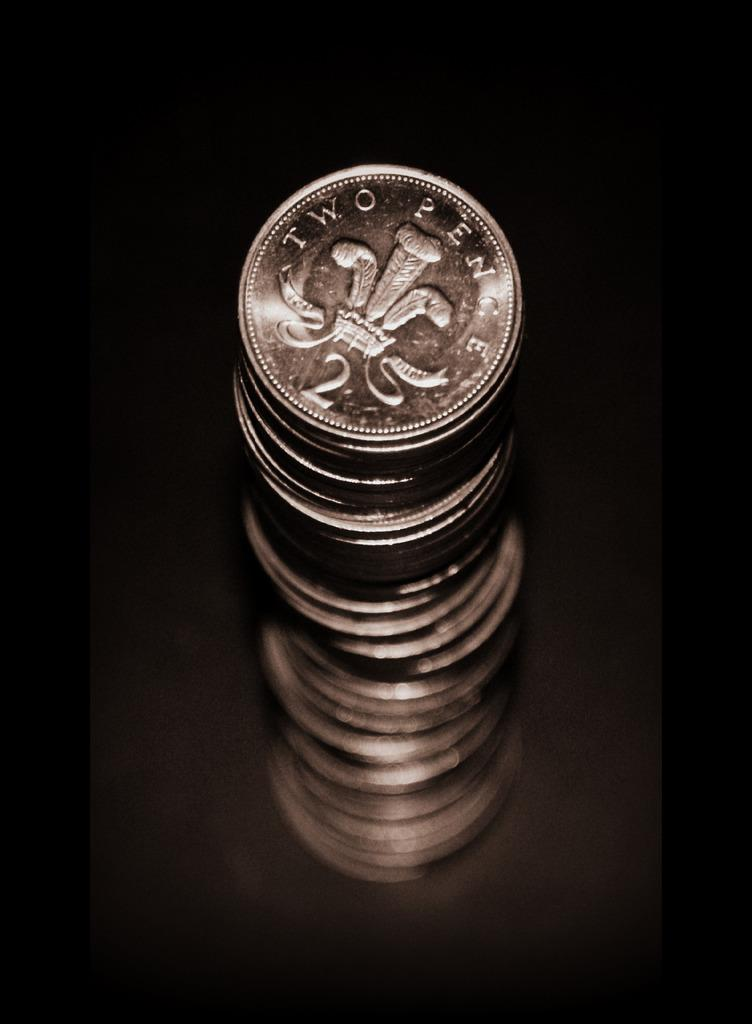<image>
Summarize the visual content of the image. Many silver coins marked two pence are sitting on the table. 